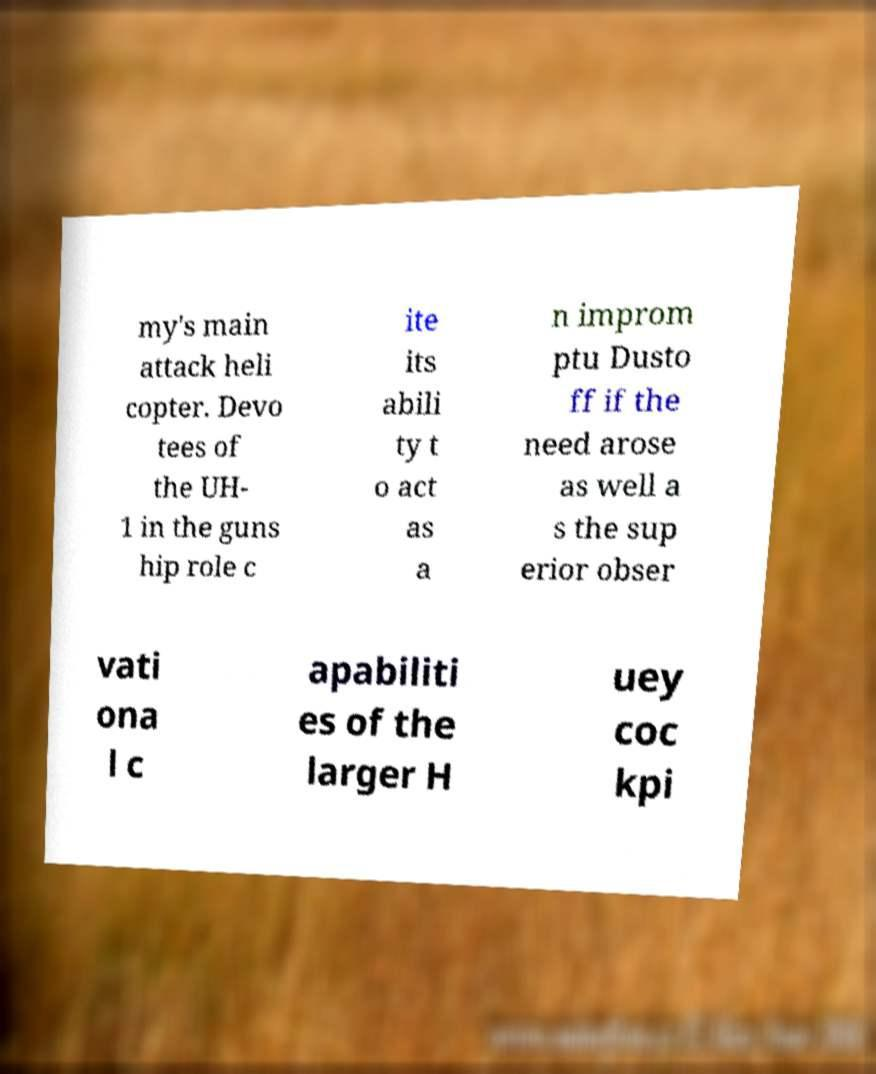What messages or text are displayed in this image? I need them in a readable, typed format. my's main attack heli copter. Devo tees of the UH- 1 in the guns hip role c ite its abili ty t o act as a n improm ptu Dusto ff if the need arose as well a s the sup erior obser vati ona l c apabiliti es of the larger H uey coc kpi 